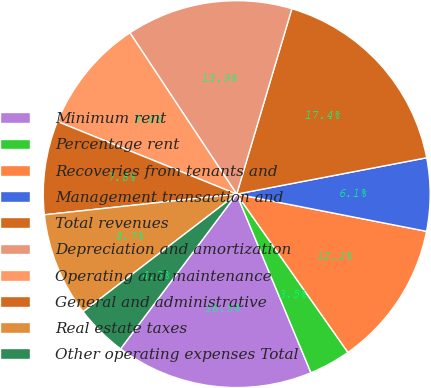<chart> <loc_0><loc_0><loc_500><loc_500><pie_chart><fcel>Minimum rent<fcel>Percentage rent<fcel>Recoveries from tenants and<fcel>Management transaction and<fcel>Total revenues<fcel>Depreciation and amortization<fcel>Operating and maintenance<fcel>General and administrative<fcel>Real estate taxes<fcel>Other operating expenses Total<nl><fcel>16.52%<fcel>3.48%<fcel>12.17%<fcel>6.09%<fcel>17.39%<fcel>13.91%<fcel>9.57%<fcel>7.83%<fcel>8.7%<fcel>4.35%<nl></chart> 